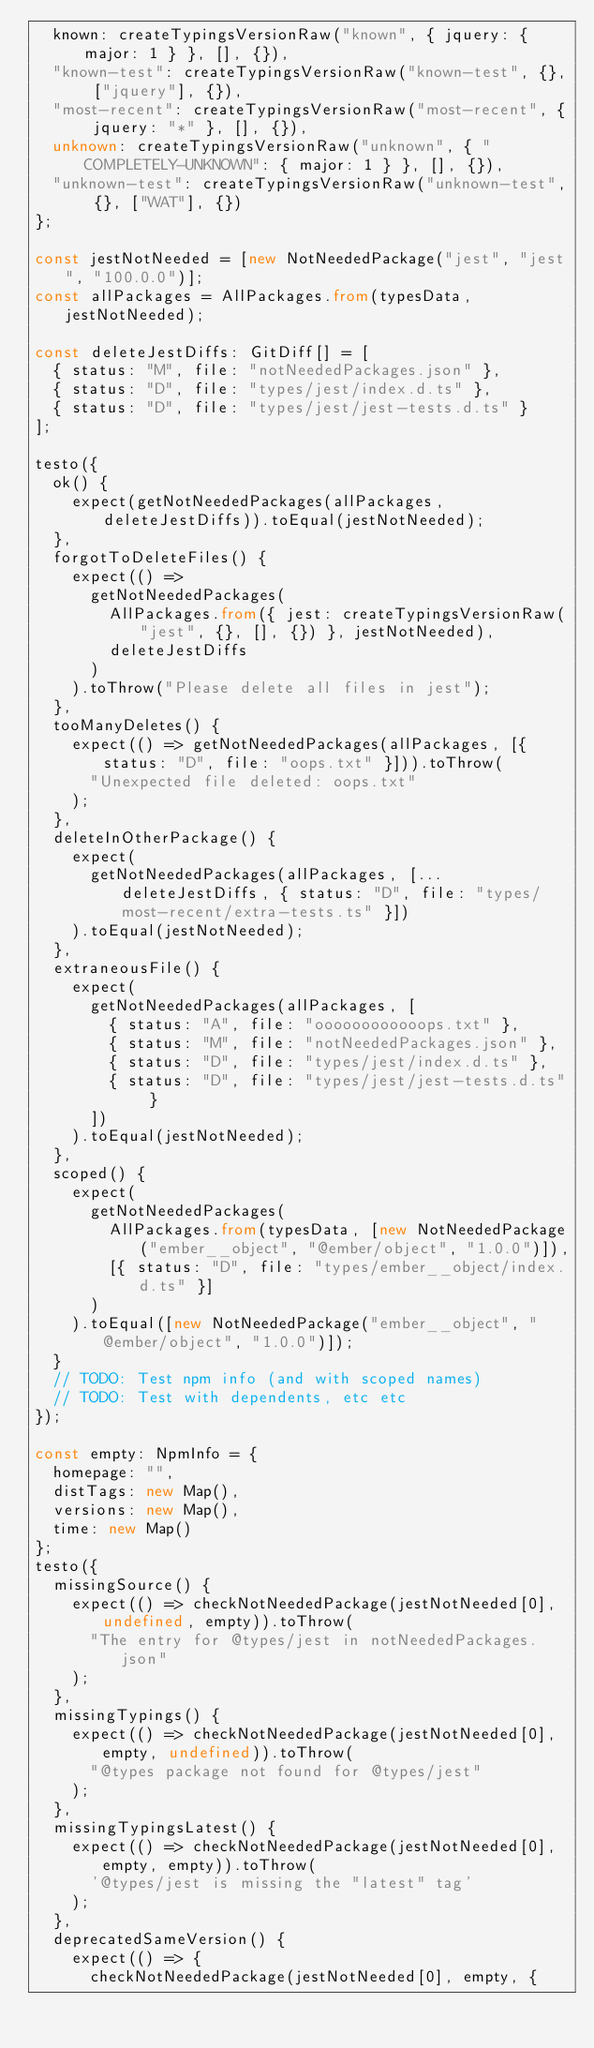Convert code to text. <code><loc_0><loc_0><loc_500><loc_500><_TypeScript_>  known: createTypingsVersionRaw("known", { jquery: { major: 1 } }, [], {}),
  "known-test": createTypingsVersionRaw("known-test", {}, ["jquery"], {}),
  "most-recent": createTypingsVersionRaw("most-recent", { jquery: "*" }, [], {}),
  unknown: createTypingsVersionRaw("unknown", { "COMPLETELY-UNKNOWN": { major: 1 } }, [], {}),
  "unknown-test": createTypingsVersionRaw("unknown-test", {}, ["WAT"], {})
};

const jestNotNeeded = [new NotNeededPackage("jest", "jest", "100.0.0")];
const allPackages = AllPackages.from(typesData, jestNotNeeded);

const deleteJestDiffs: GitDiff[] = [
  { status: "M", file: "notNeededPackages.json" },
  { status: "D", file: "types/jest/index.d.ts" },
  { status: "D", file: "types/jest/jest-tests.d.ts" }
];

testo({
  ok() {
    expect(getNotNeededPackages(allPackages, deleteJestDiffs)).toEqual(jestNotNeeded);
  },
  forgotToDeleteFiles() {
    expect(() =>
      getNotNeededPackages(
        AllPackages.from({ jest: createTypingsVersionRaw("jest", {}, [], {}) }, jestNotNeeded),
        deleteJestDiffs
      )
    ).toThrow("Please delete all files in jest");
  },
  tooManyDeletes() {
    expect(() => getNotNeededPackages(allPackages, [{ status: "D", file: "oops.txt" }])).toThrow(
      "Unexpected file deleted: oops.txt"
    );
  },
  deleteInOtherPackage() {
    expect(
      getNotNeededPackages(allPackages, [...deleteJestDiffs, { status: "D", file: "types/most-recent/extra-tests.ts" }])
    ).toEqual(jestNotNeeded);
  },
  extraneousFile() {
    expect(
      getNotNeededPackages(allPackages, [
        { status: "A", file: "oooooooooooops.txt" },
        { status: "M", file: "notNeededPackages.json" },
        { status: "D", file: "types/jest/index.d.ts" },
        { status: "D", file: "types/jest/jest-tests.d.ts" }
      ])
    ).toEqual(jestNotNeeded);
  },
  scoped() {
    expect(
      getNotNeededPackages(
        AllPackages.from(typesData, [new NotNeededPackage("ember__object", "@ember/object", "1.0.0")]),
        [{ status: "D", file: "types/ember__object/index.d.ts" }]
      )
    ).toEqual([new NotNeededPackage("ember__object", "@ember/object", "1.0.0")]);
  }
  // TODO: Test npm info (and with scoped names)
  // TODO: Test with dependents, etc etc
});

const empty: NpmInfo = {
  homepage: "",
  distTags: new Map(),
  versions: new Map(),
  time: new Map()
};
testo({
  missingSource() {
    expect(() => checkNotNeededPackage(jestNotNeeded[0], undefined, empty)).toThrow(
      "The entry for @types/jest in notNeededPackages.json"
    );
  },
  missingTypings() {
    expect(() => checkNotNeededPackage(jestNotNeeded[0], empty, undefined)).toThrow(
      "@types package not found for @types/jest"
    );
  },
  missingTypingsLatest() {
    expect(() => checkNotNeededPackage(jestNotNeeded[0], empty, empty)).toThrow(
      '@types/jest is missing the "latest" tag'
    );
  },
  deprecatedSameVersion() {
    expect(() => {
      checkNotNeededPackage(jestNotNeeded[0], empty, {</code> 